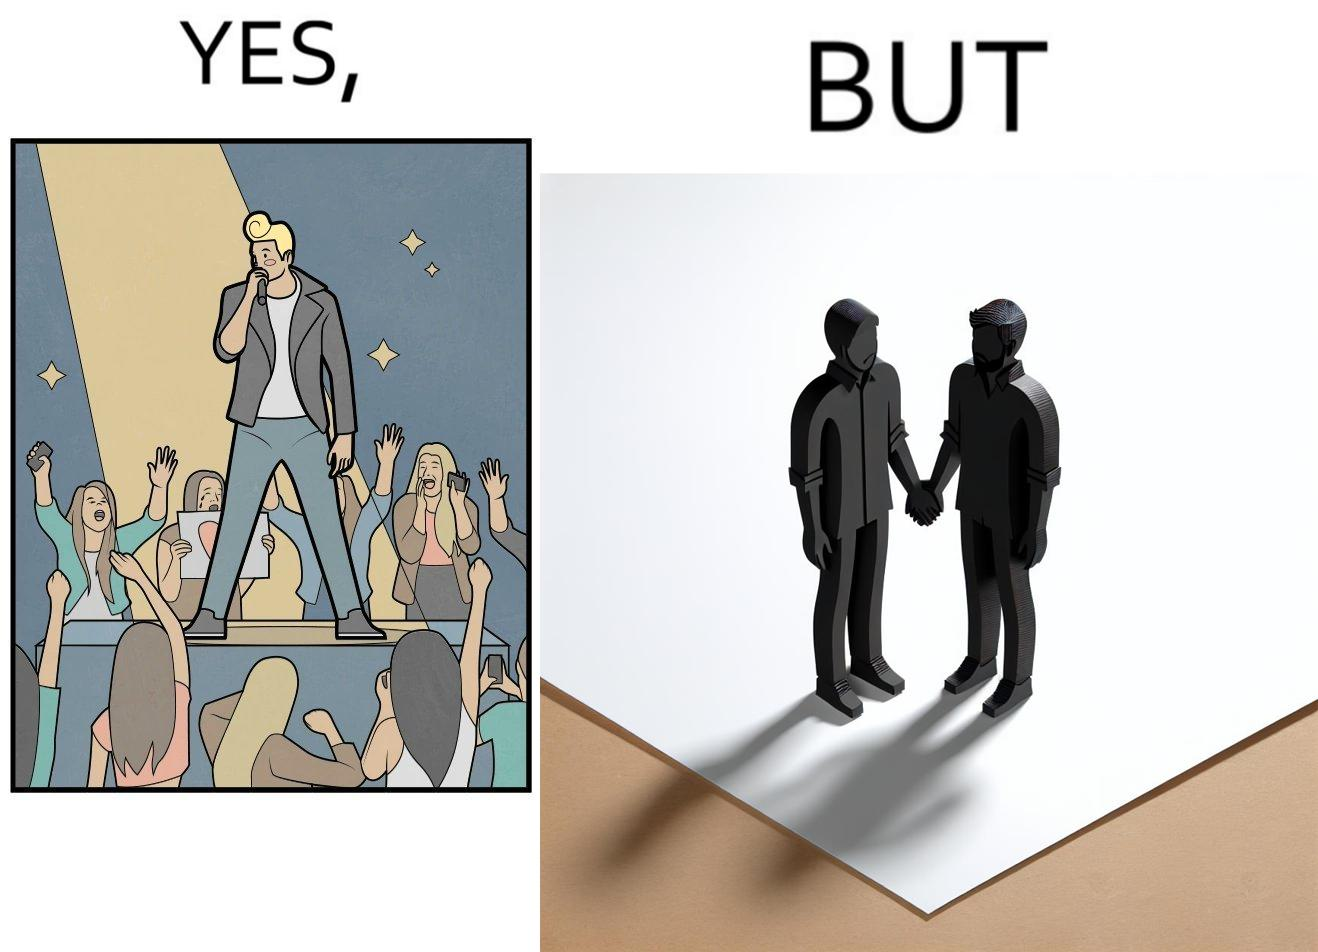Provide a description of this image. The image is funny because while the girls loves the man, he likes other men instead of women. 